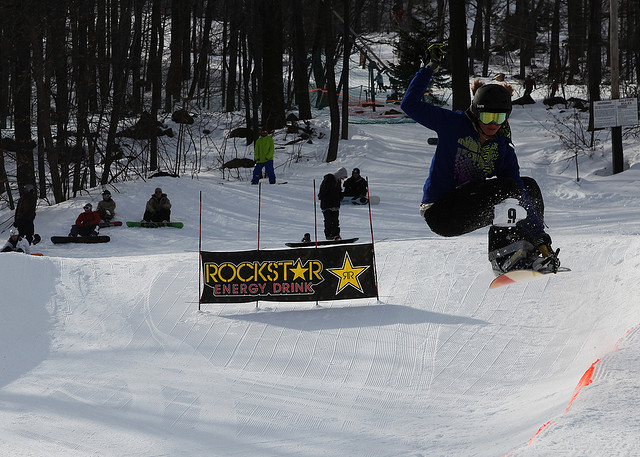<image>What does the board say? I don't know what the board says. It could say 'rockstar', 'rockstar energy drink', 'burton' or '9'. What does the board say? The board says "rockstar energy drink". 